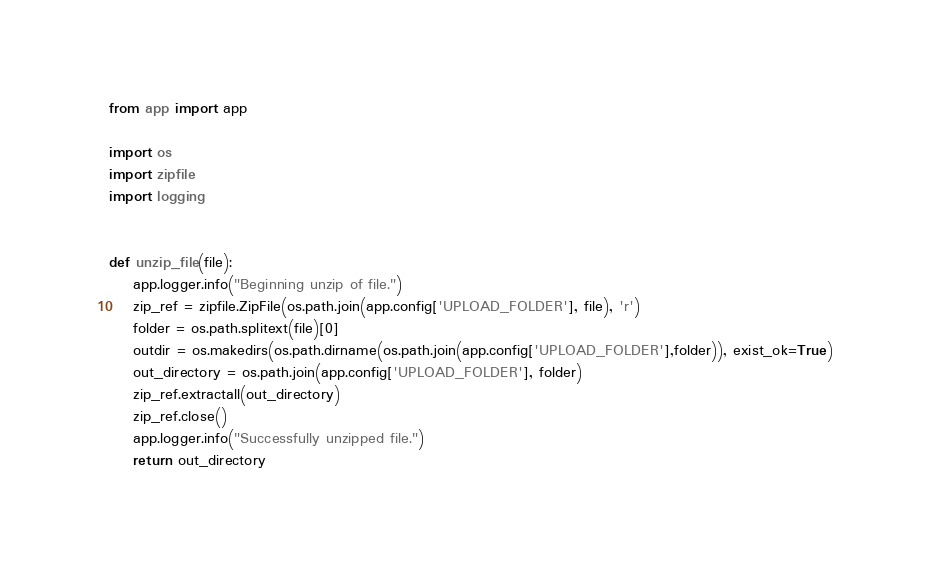Convert code to text. <code><loc_0><loc_0><loc_500><loc_500><_Python_>from app import app

import os
import zipfile
import logging


def unzip_file(file):
    app.logger.info("Beginning unzip of file.")
    zip_ref = zipfile.ZipFile(os.path.join(app.config['UPLOAD_FOLDER'], file), 'r')
    folder = os.path.splitext(file)[0]
    outdir = os.makedirs(os.path.dirname(os.path.join(app.config['UPLOAD_FOLDER'],folder)), exist_ok=True)
    out_directory = os.path.join(app.config['UPLOAD_FOLDER'], folder)
    zip_ref.extractall(out_directory)
    zip_ref.close()
    app.logger.info("Successfully unzipped file.")
    return out_directory</code> 